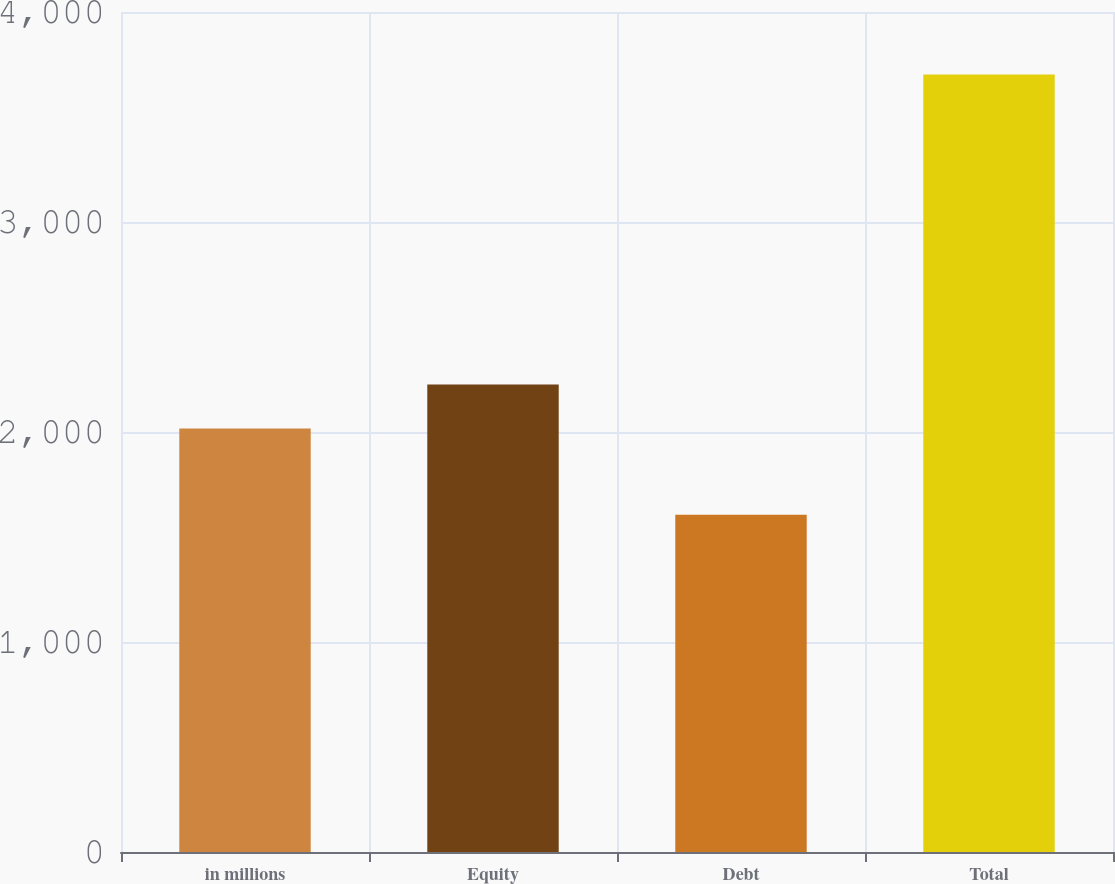<chart> <loc_0><loc_0><loc_500><loc_500><bar_chart><fcel>in millions<fcel>Equity<fcel>Debt<fcel>Total<nl><fcel>2017<fcel>2226.6<fcel>1606<fcel>3702<nl></chart> 